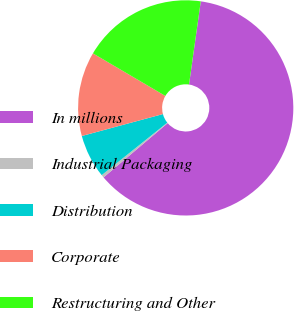<chart> <loc_0><loc_0><loc_500><loc_500><pie_chart><fcel>In millions<fcel>Industrial Packaging<fcel>Distribution<fcel>Corporate<fcel>Restructuring and Other<nl><fcel>61.59%<fcel>0.43%<fcel>6.54%<fcel>12.66%<fcel>18.78%<nl></chart> 